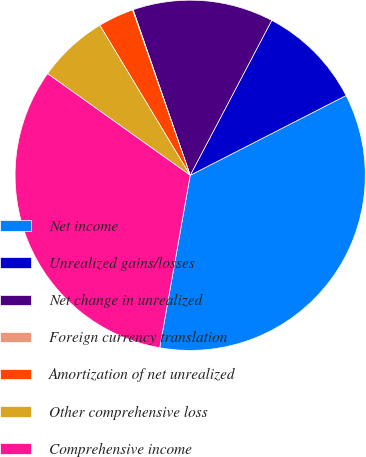Convert chart to OTSL. <chart><loc_0><loc_0><loc_500><loc_500><pie_chart><fcel>Net income<fcel>Unrealized gains/losses<fcel>Net change in unrealized<fcel>Foreign currency translation<fcel>Amortization of net unrealized<fcel>Other comprehensive loss<fcel>Comprehensive income<nl><fcel>35.31%<fcel>9.76%<fcel>12.99%<fcel>0.06%<fcel>3.29%<fcel>6.52%<fcel>32.07%<nl></chart> 